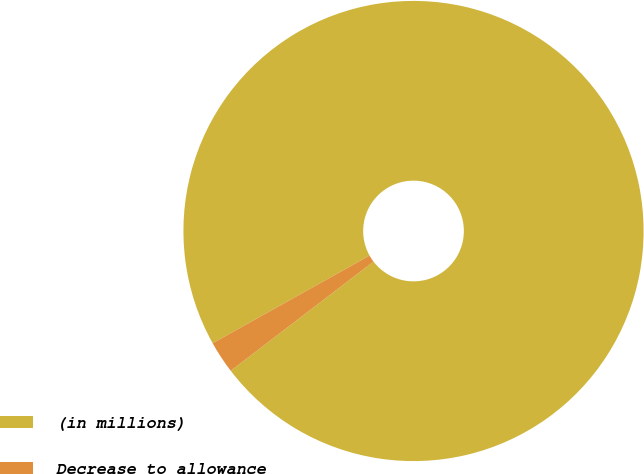Convert chart. <chart><loc_0><loc_0><loc_500><loc_500><pie_chart><fcel>(in millions)<fcel>Decrease to allowance<nl><fcel>97.72%<fcel>2.28%<nl></chart> 